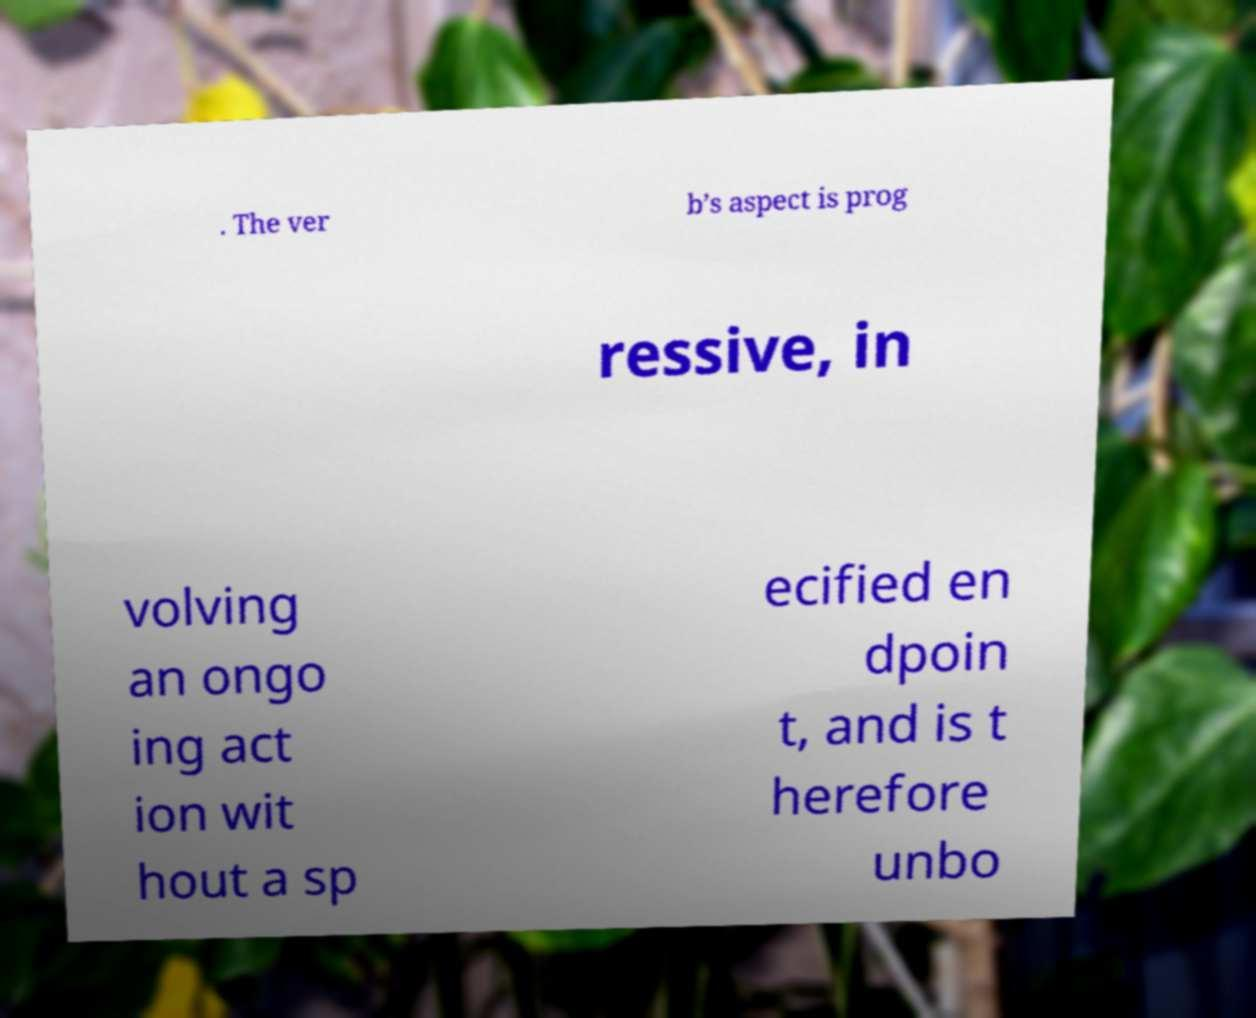Please read and relay the text visible in this image. What does it say? . The ver b’s aspect is prog ressive, in volving an ongo ing act ion wit hout a sp ecified en dpoin t, and is t herefore unbo 